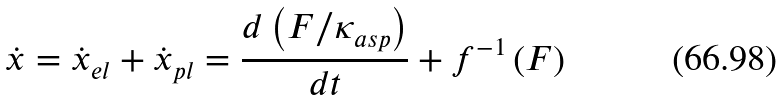Convert formula to latex. <formula><loc_0><loc_0><loc_500><loc_500>\dot { x } = \dot { x } _ { e l } + \dot { x } _ { p l } = \frac { d \left ( F / \kappa _ { a s p } \right ) } { d t } + f ^ { - 1 } \left ( F \right )</formula> 